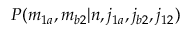Convert formula to latex. <formula><loc_0><loc_0><loc_500><loc_500>P ( m _ { 1 a } , m _ { b 2 } | n , j _ { 1 a } , j _ { b 2 } , j _ { 1 2 } )</formula> 